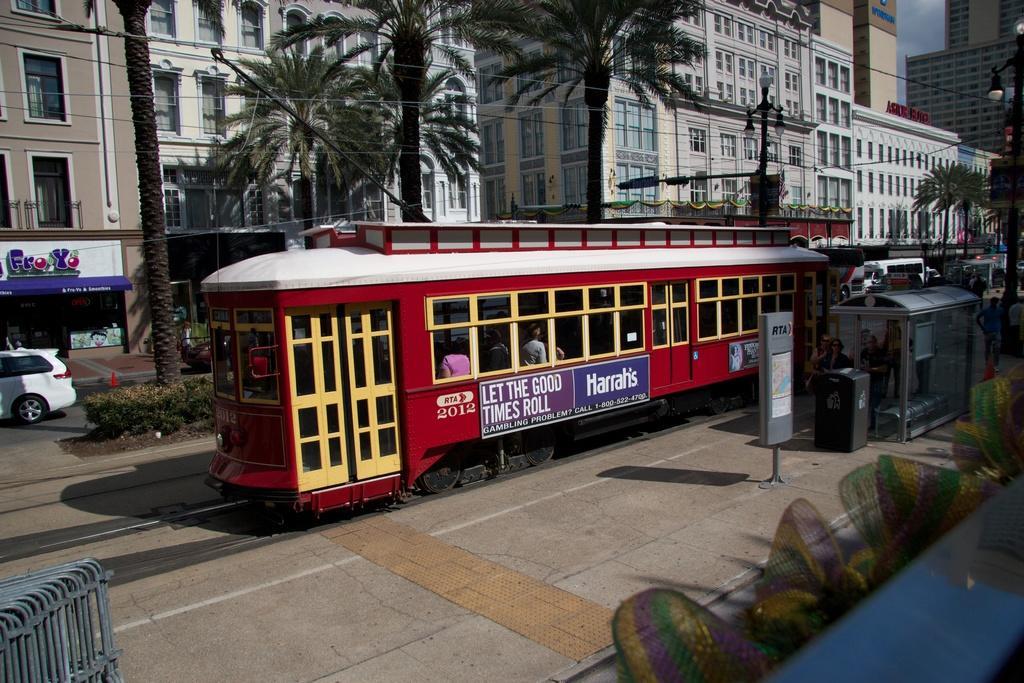Could you give a brief overview of what you see in this image? This image is taken outdoors. At the bottom of the image there is a sidewalk. There is a table. There are a few chairs. There are a few objects. In the background there are many buildings. There are a few boards with text on them. There are a few poles with street lights. There are a few trees. On the left side of the image a car is moving on the road and there are a few plants. In the middle of the image a train is moving on the track. 